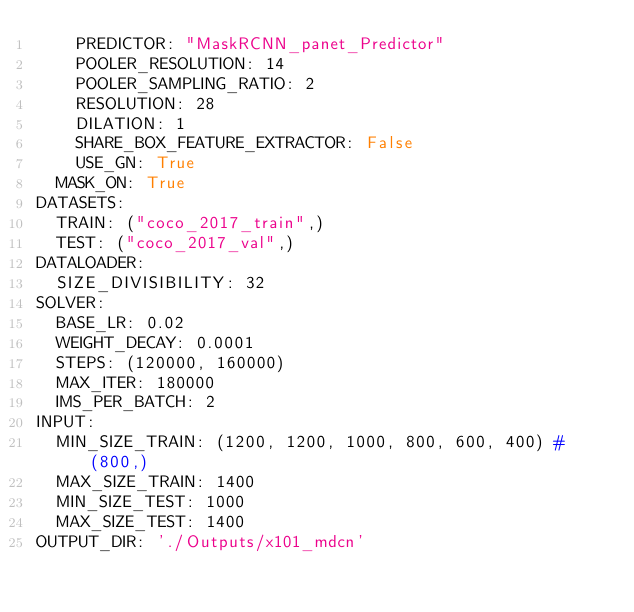Convert code to text. <code><loc_0><loc_0><loc_500><loc_500><_YAML_>    PREDICTOR: "MaskRCNN_panet_Predictor"
    POOLER_RESOLUTION: 14
    POOLER_SAMPLING_RATIO: 2
    RESOLUTION: 28
    DILATION: 1
    SHARE_BOX_FEATURE_EXTRACTOR: False
    USE_GN: True
  MASK_ON: True
DATASETS:
  TRAIN: ("coco_2017_train",)
  TEST: ("coco_2017_val",)
DATALOADER:
  SIZE_DIVISIBILITY: 32
SOLVER:
  BASE_LR: 0.02
  WEIGHT_DECAY: 0.0001
  STEPS: (120000, 160000)
  MAX_ITER: 180000
  IMS_PER_BATCH: 2
INPUT:
  MIN_SIZE_TRAIN: (1200, 1200, 1000, 800, 600, 400) # (800,)
  MAX_SIZE_TRAIN: 1400
  MIN_SIZE_TEST: 1000
  MAX_SIZE_TEST: 1400
OUTPUT_DIR: './Outputs/x101_mdcn'
</code> 